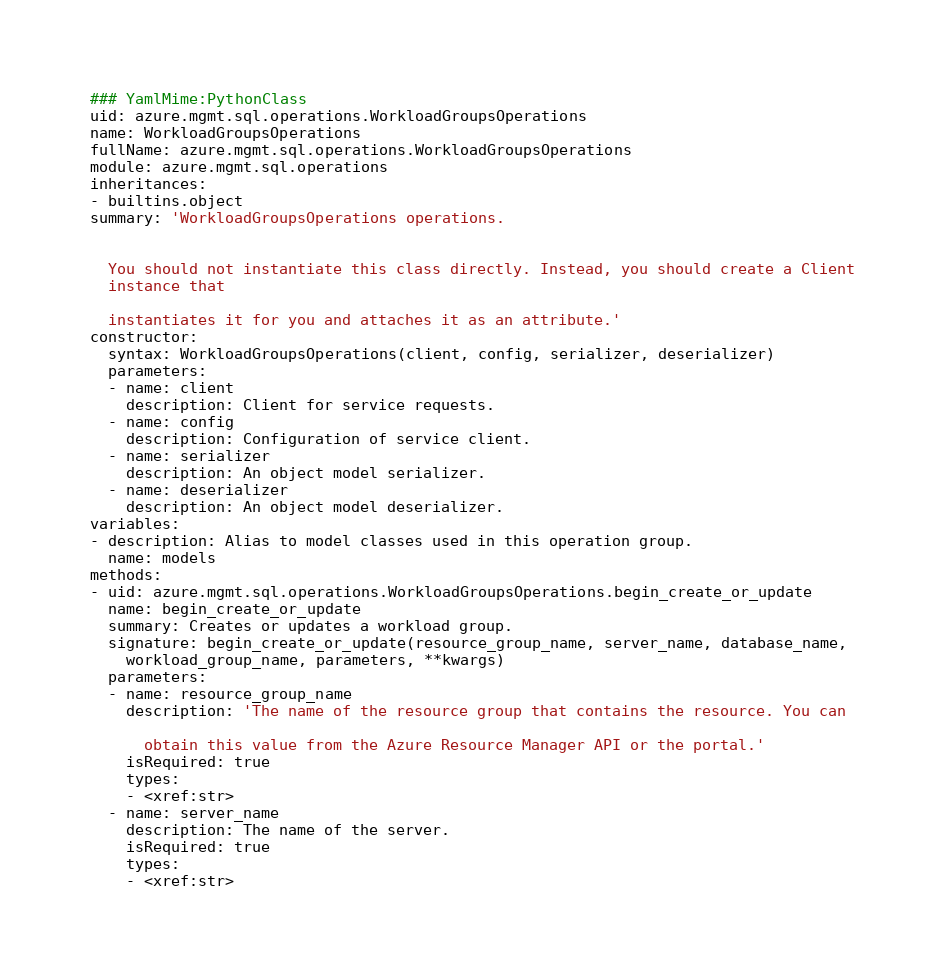<code> <loc_0><loc_0><loc_500><loc_500><_YAML_>### YamlMime:PythonClass
uid: azure.mgmt.sql.operations.WorkloadGroupsOperations
name: WorkloadGroupsOperations
fullName: azure.mgmt.sql.operations.WorkloadGroupsOperations
module: azure.mgmt.sql.operations
inheritances:
- builtins.object
summary: 'WorkloadGroupsOperations operations.


  You should not instantiate this class directly. Instead, you should create a Client
  instance that

  instantiates it for you and attaches it as an attribute.'
constructor:
  syntax: WorkloadGroupsOperations(client, config, serializer, deserializer)
  parameters:
  - name: client
    description: Client for service requests.
  - name: config
    description: Configuration of service client.
  - name: serializer
    description: An object model serializer.
  - name: deserializer
    description: An object model deserializer.
variables:
- description: Alias to model classes used in this operation group.
  name: models
methods:
- uid: azure.mgmt.sql.operations.WorkloadGroupsOperations.begin_create_or_update
  name: begin_create_or_update
  summary: Creates or updates a workload group.
  signature: begin_create_or_update(resource_group_name, server_name, database_name,
    workload_group_name, parameters, **kwargs)
  parameters:
  - name: resource_group_name
    description: 'The name of the resource group that contains the resource. You can

      obtain this value from the Azure Resource Manager API or the portal.'
    isRequired: true
    types:
    - <xref:str>
  - name: server_name
    description: The name of the server.
    isRequired: true
    types:
    - <xref:str></code> 